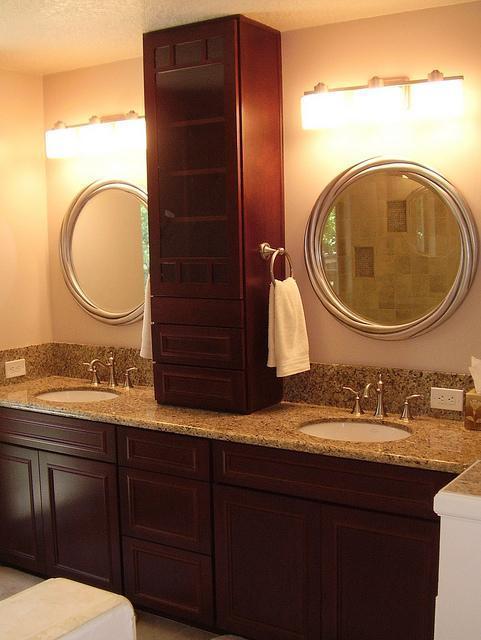How many mirrors are here?
Give a very brief answer. 2. 